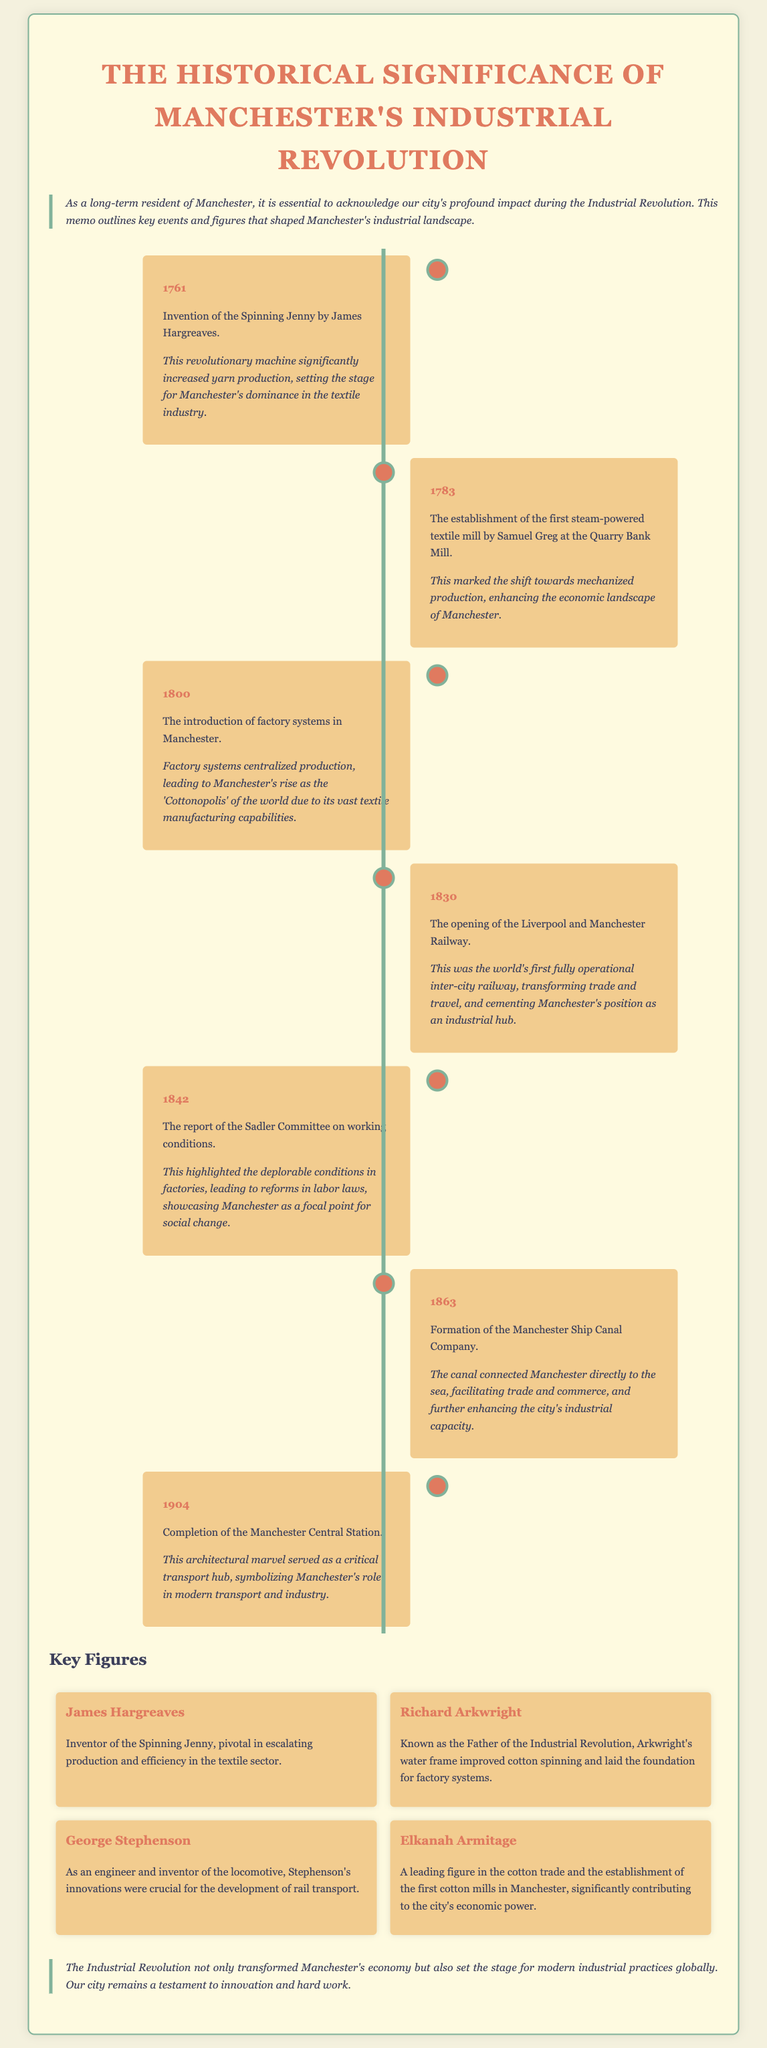What year was the Spinning Jenny invented? The document states that the Spinning Jenny was invented in 1761.
Answer: 1761 Who established the first steam-powered textile mill? Samuel Greg is noted in the document as the founder of the first steam-powered textile mill.
Answer: Samuel Greg What was the nickname given to Manchester due to its textile manufacturing? The document refers to Manchester as 'Cottonopolis' because of its vast textile production capabilities.
Answer: Cottonopolis What significant railway opened in 1830? The opening of the Liverpool and Manchester Railway is highlighted in the document as a key event.
Answer: Liverpool and Manchester Railway Who is known as the Father of the Industrial Revolution? Richard Arkwright is mentioned in the document as the Father of the Industrial Revolution.
Answer: Richard Arkwright What year did the Sadler Committee report on working conditions? The document states that the Sadler Committee report was released in 1842.
Answer: 1842 What infrastructure project connected Manchester directly to the sea? The document highlights the formation of the Manchester Ship Canal Company as the project that connected Manchester to the sea.
Answer: Manchester Ship Canal What year was the Manchester Central Station completed? The document mentions that the Manchester Central Station was completed in 1904.
Answer: 1904 What invention did George Stephenson contribute to the railway industry? George Stephenson is credited in the document as the inventor of the locomotive.
Answer: Locomotive 